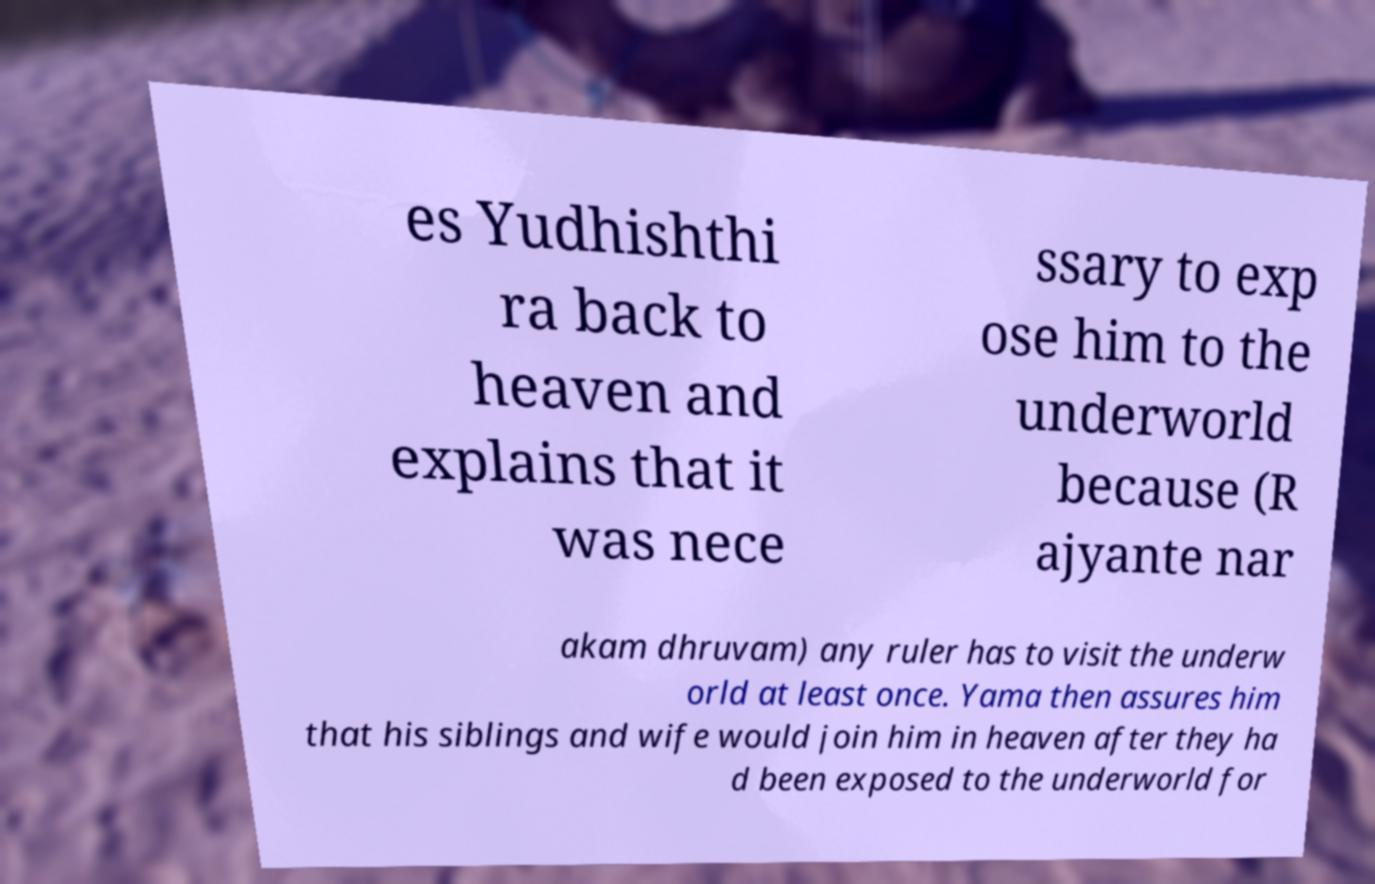Can you accurately transcribe the text from the provided image for me? es Yudhishthi ra back to heaven and explains that it was nece ssary to exp ose him to the underworld because (R ajyante nar akam dhruvam) any ruler has to visit the underw orld at least once. Yama then assures him that his siblings and wife would join him in heaven after they ha d been exposed to the underworld for 